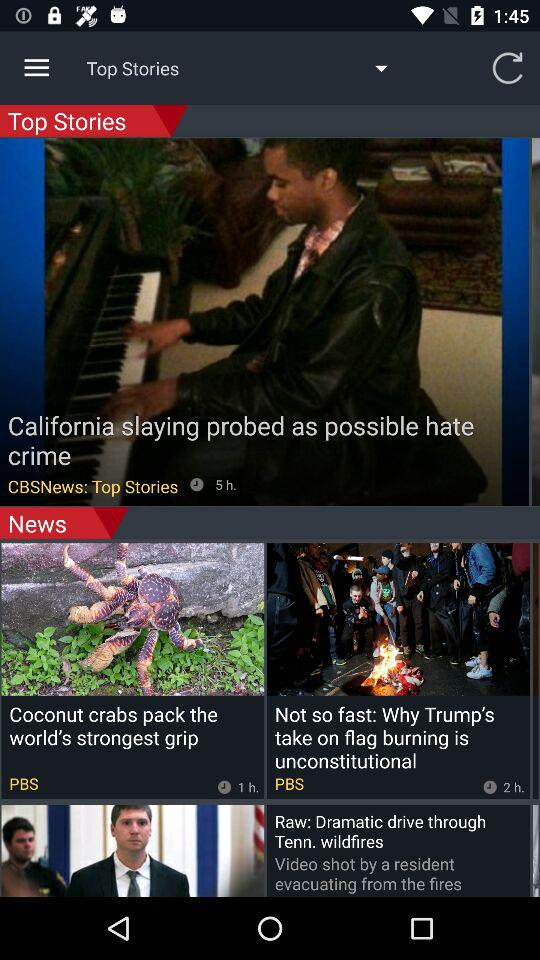What's the news in the top stories? The news in the top stories is "California slaying probed as possible hate crime". 